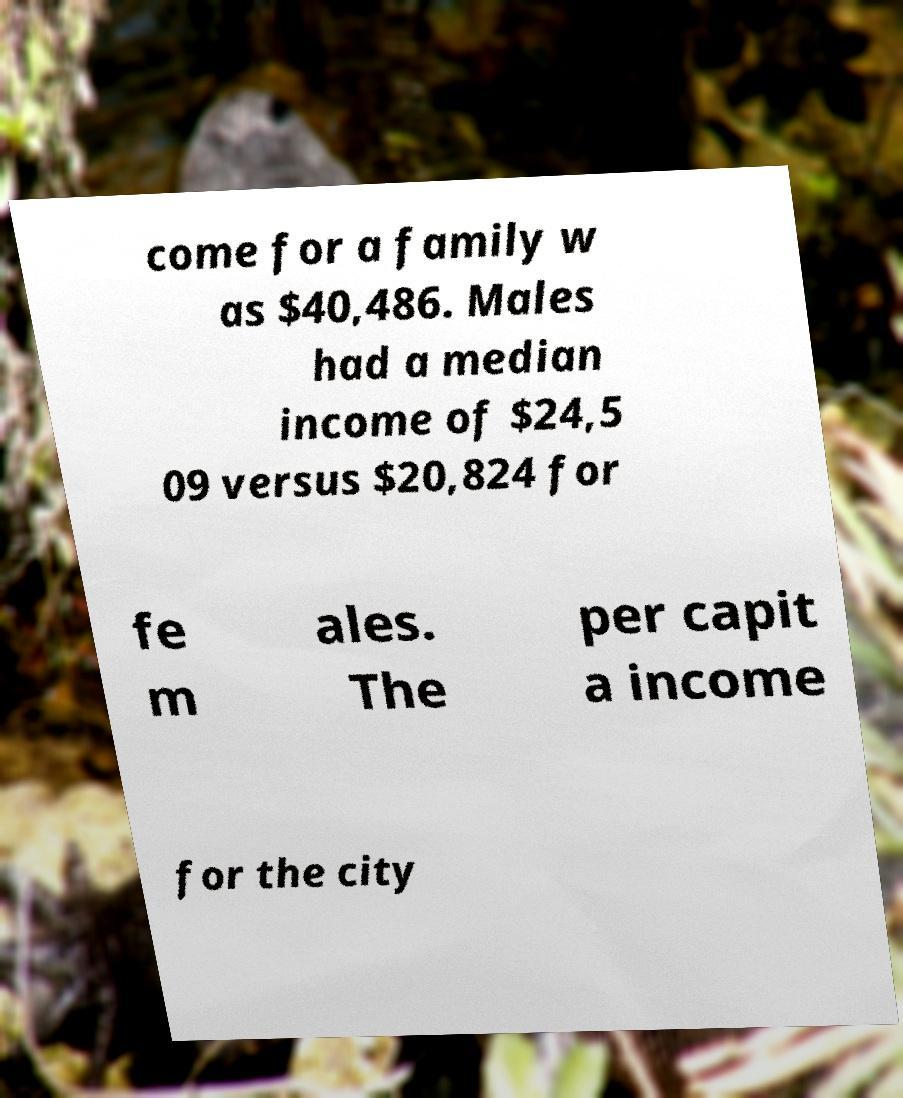Could you assist in decoding the text presented in this image and type it out clearly? come for a family w as $40,486. Males had a median income of $24,5 09 versus $20,824 for fe m ales. The per capit a income for the city 